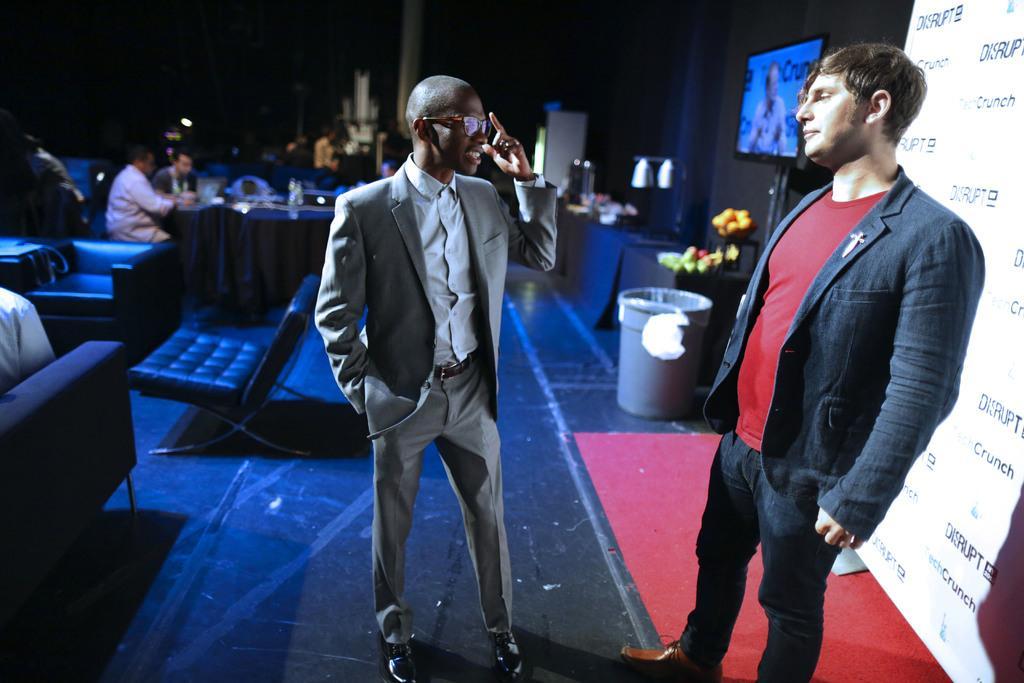How would you summarize this image in a sentence or two? As we can see in the image there are few people here and there, banner, screen, bucket, sofas and table. The image is little dark. 